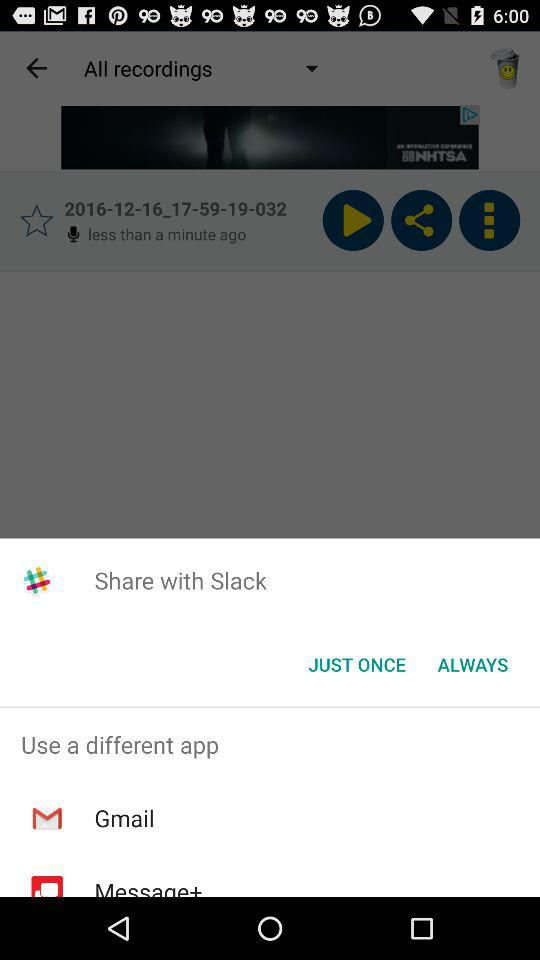How many different apps can be used to share the recording?
Answer the question using a single word or phrase. 2 